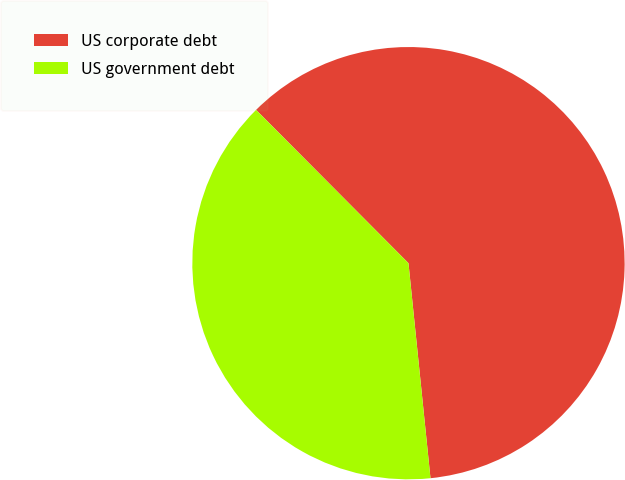Convert chart to OTSL. <chart><loc_0><loc_0><loc_500><loc_500><pie_chart><fcel>US corporate debt<fcel>US government debt<nl><fcel>60.83%<fcel>39.17%<nl></chart> 